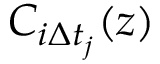Convert formula to latex. <formula><loc_0><loc_0><loc_500><loc_500>C _ { i \Delta t _ { j } } ( z )</formula> 